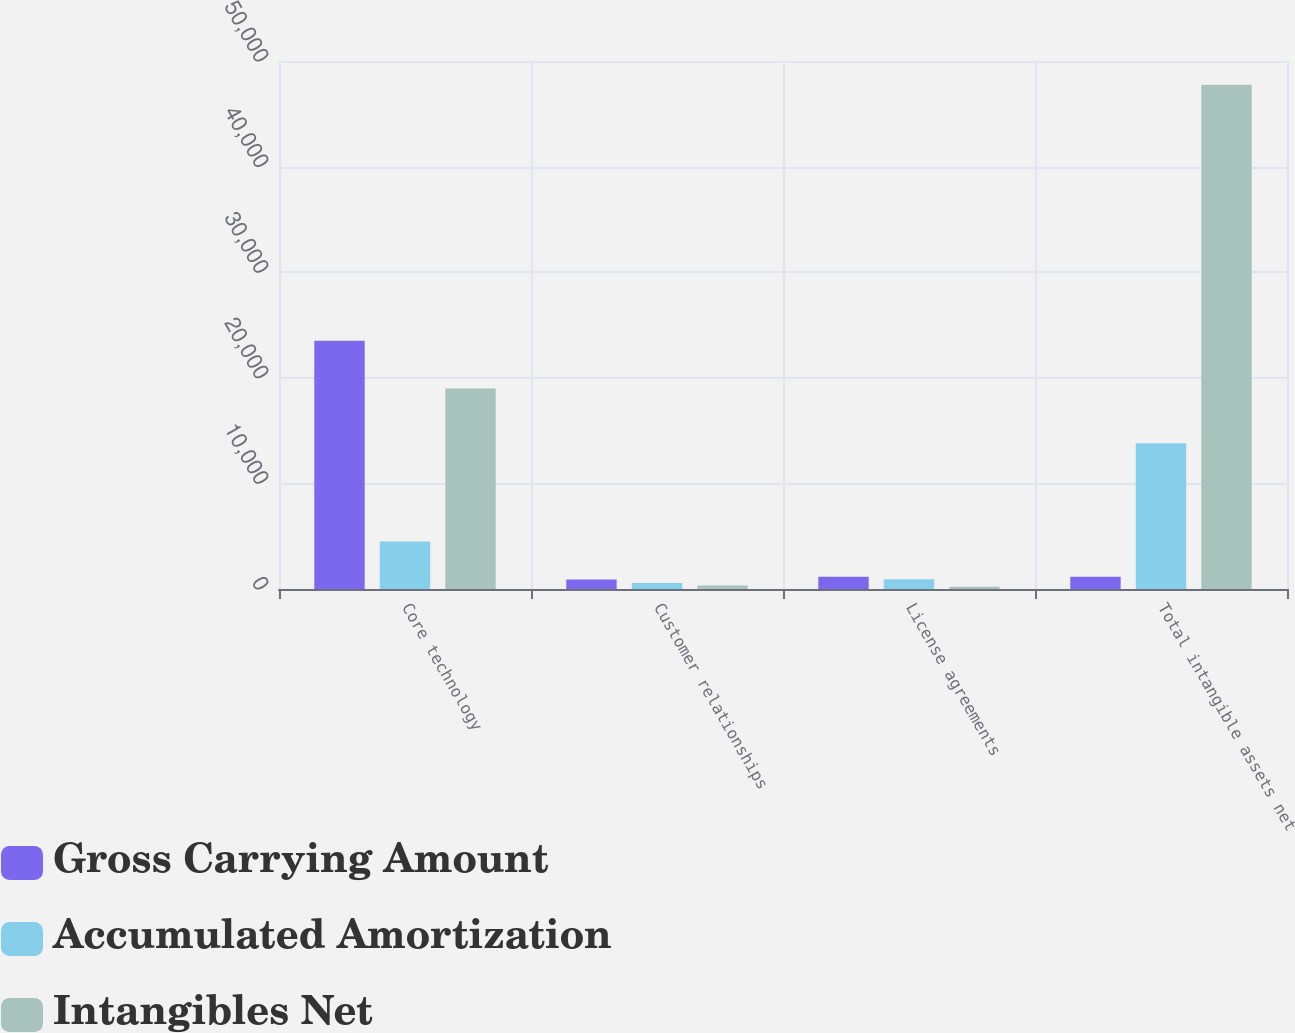Convert chart. <chart><loc_0><loc_0><loc_500><loc_500><stacked_bar_chart><ecel><fcel>Core technology<fcel>Customer relationships<fcel>License agreements<fcel>Total intangible assets net<nl><fcel>Gross Carrying Amount<fcel>23500<fcel>900<fcel>1154<fcel>1154<nl><fcel>Accumulated Amortization<fcel>4504<fcel>575<fcel>932<fcel>13799<nl><fcel>Intangibles Net<fcel>18996<fcel>325<fcel>222<fcel>47755<nl></chart> 